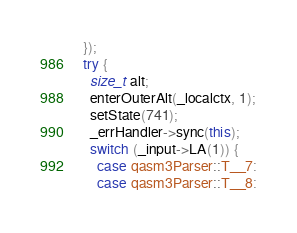Convert code to text. <code><loc_0><loc_0><loc_500><loc_500><_C++_>  });
  try {
    size_t alt;
    enterOuterAlt(_localctx, 1);
    setState(741);
    _errHandler->sync(this);
    switch (_input->LA(1)) {
      case qasm3Parser::T__7:
      case qasm3Parser::T__8:</code> 